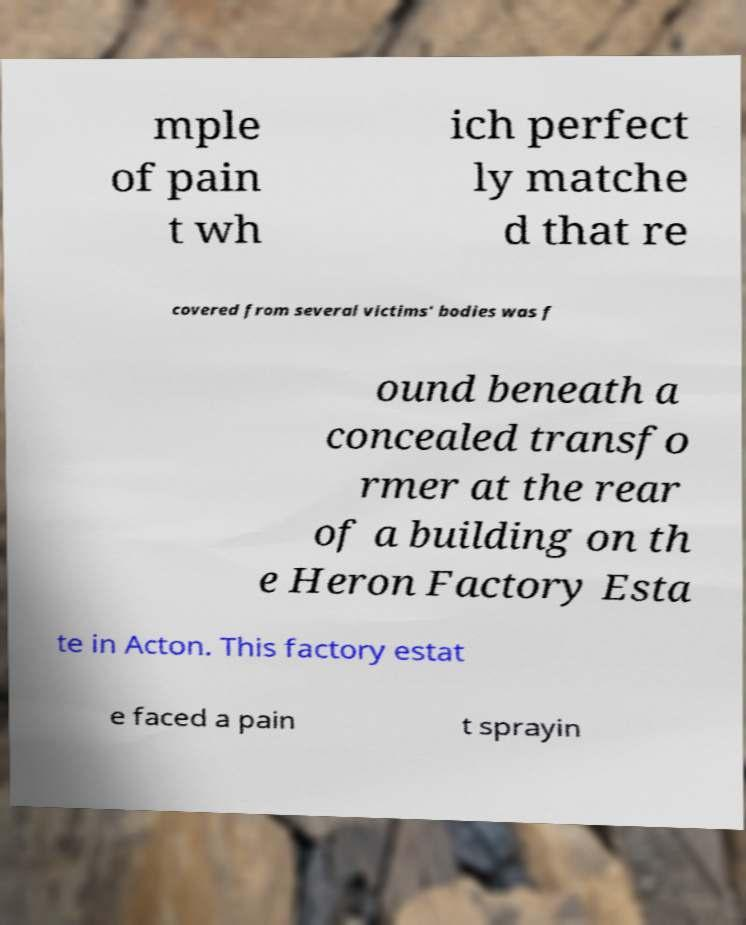I need the written content from this picture converted into text. Can you do that? mple of pain t wh ich perfect ly matche d that re covered from several victims' bodies was f ound beneath a concealed transfo rmer at the rear of a building on th e Heron Factory Esta te in Acton. This factory estat e faced a pain t sprayin 